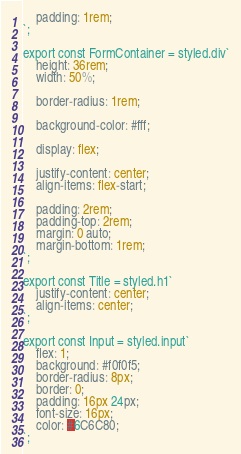<code> <loc_0><loc_0><loc_500><loc_500><_TypeScript_>    padding: 1rem;
`;

export const FormContainer = styled.div`
    height: 36rem;
    width: 50%;

    border-radius: 1rem;

    background-color: #fff;

    display: flex;

    justify-content: center;
    align-items: flex-start;

    padding: 2rem;
    padding-top: 2rem;
    margin: 0 auto;
    margin-bottom: 1rem;
`;

export const Title = styled.h1`
    justify-content: center;
    align-items: center;
`;

export const Input = styled.input`
    flex: 1;
    background: #f0f0f5;
    border-radius: 8px;
    border: 0;
    padding: 16px 24px;
    font-size: 16px;
    color: #6C6C80;
`;</code> 